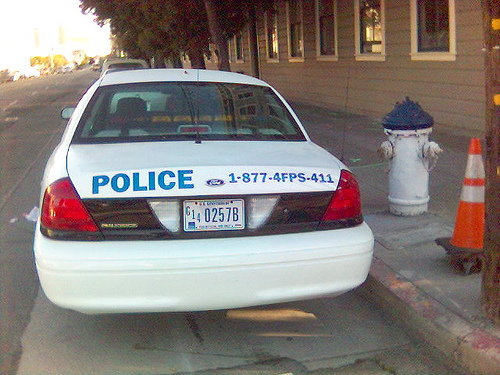Extract all visible text content from this image. POLICE 1 877 4FPS 411 4 1 6 0257B 